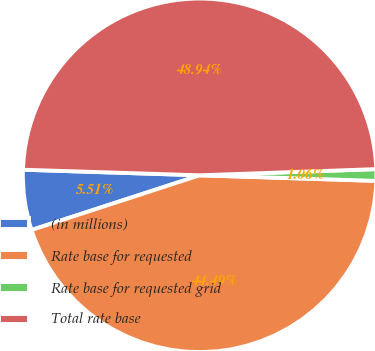Convert chart. <chart><loc_0><loc_0><loc_500><loc_500><pie_chart><fcel>(in millions)<fcel>Rate base for requested<fcel>Rate base for requested grid<fcel>Total rate base<nl><fcel>5.51%<fcel>44.49%<fcel>1.06%<fcel>48.94%<nl></chart> 